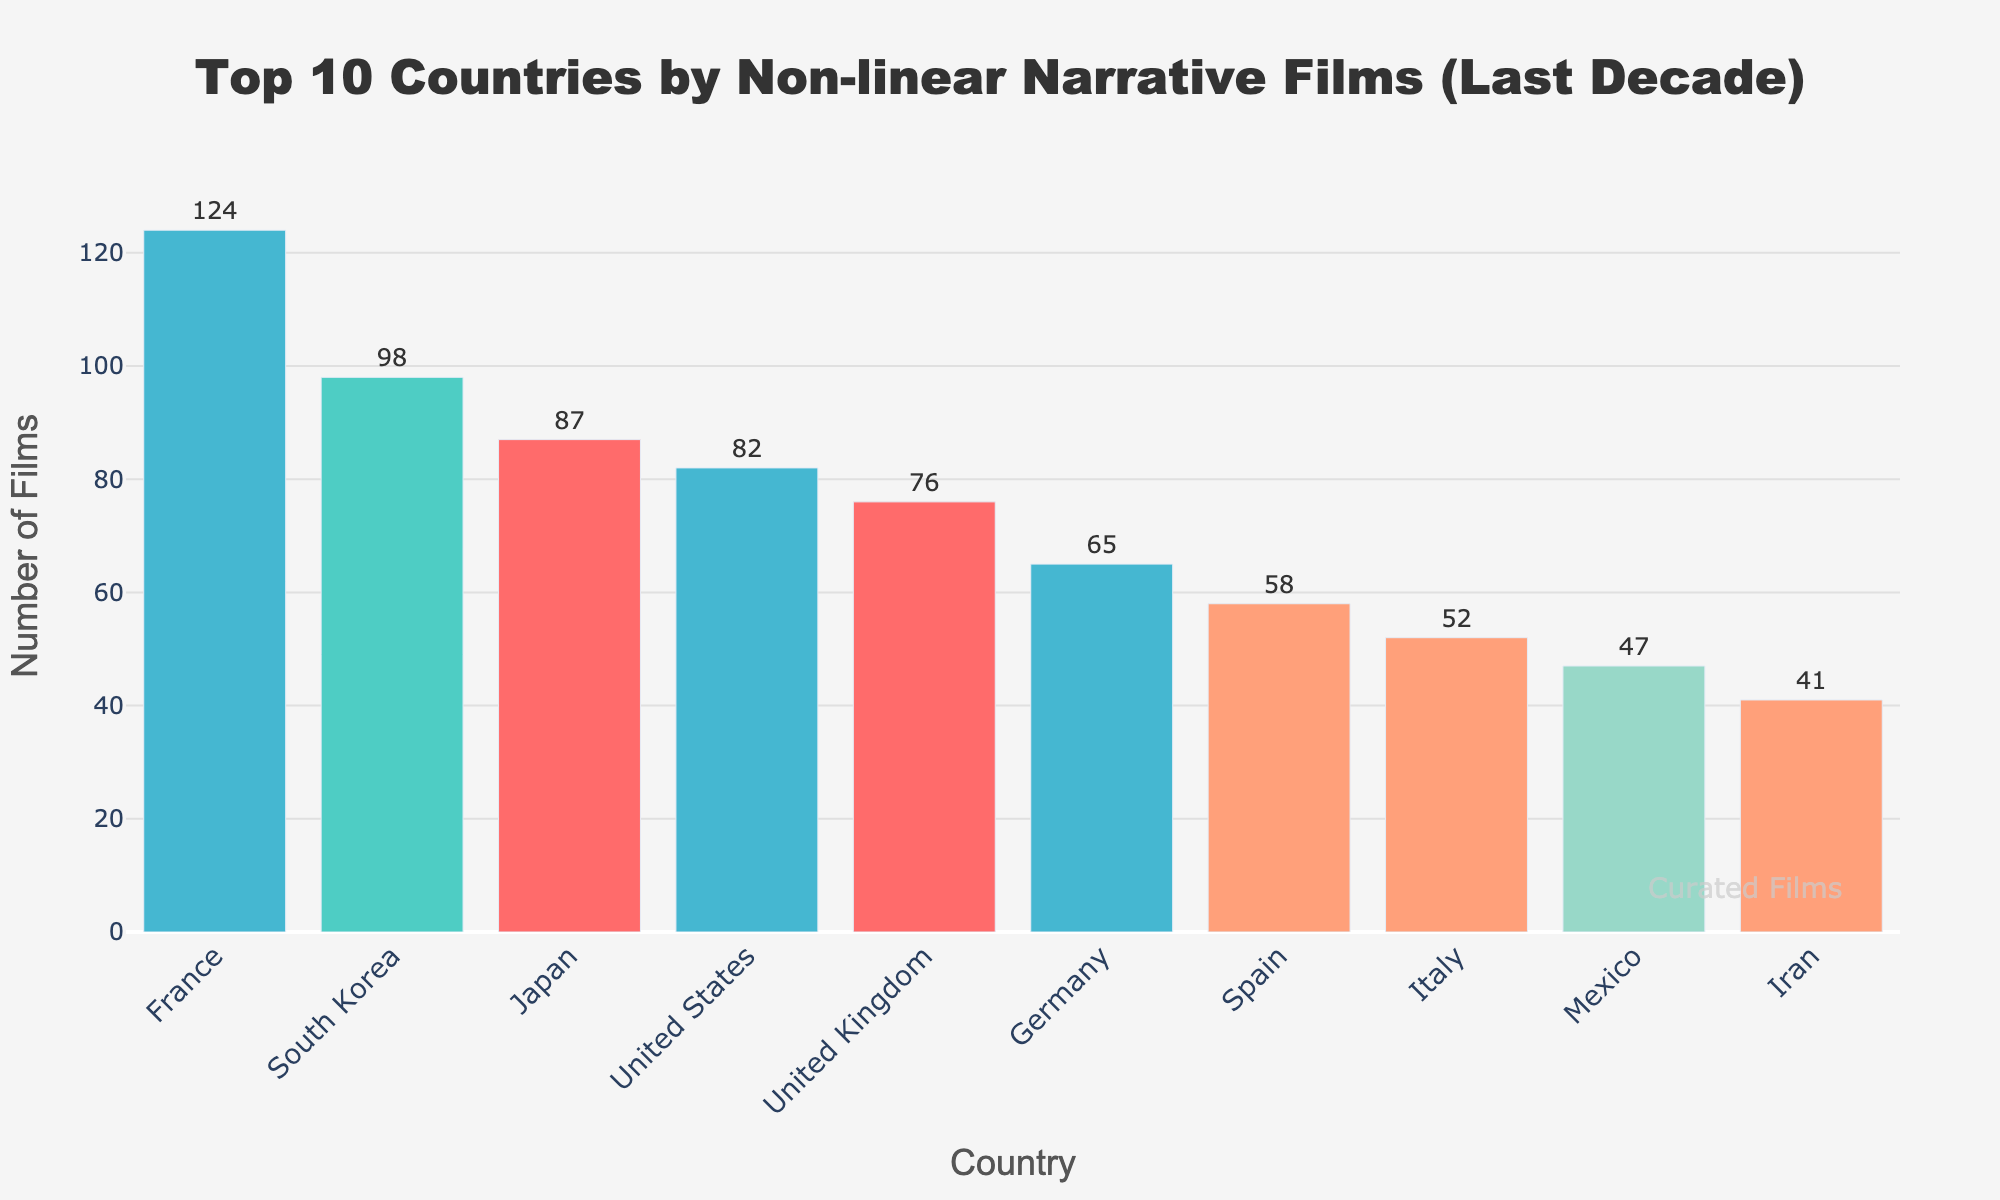what country produced the most non-linear narrative films? France produced the most non-linear narrative films with 124 films. This is observed by looking at the height of the bars where France's bar is the tallest.
Answer: France which country produced fewer non-linear narrative films, Spain or Germany? Germany produced more non-linear narrative films than Spain. Observing the bars, Germany's bar is taller with 65 films, while Spain's bar has 58 films.
Answer: Spain what is the combined total of non-linear narrative films produced by Japan and Mexico? Japan produced 87 films and Mexico produced 47 films. Adding these two numbers gives the combined total: 87 + 47 = 134.
Answer: 134 how many more non-linear narrative films did France produce compared to Italy? France produced 124 films and Italy produced 52 films. The difference is 124 - 52 = 72 films.
Answer: 72 which countries produced more than 80 non-linear narrative films? The countries that produced more than 80 films are France, South Korea, Japan, and the United States. This is determined by observing the bars that reach above the 80-mark on the y-axis.
Answer: France, South Korea, Japan, United States what is the average number of non-linear narrative films produced by the top three countries? The top three countries are France, South Korea, and Japan, producing 124, 98, and 87 films respectively. The average is calculated by summing these numbers: 124 + 98 + 87 = 309, then dividing by 3. 309 / 3 = 103.
Answer: 103 what is the difference in non-linear narrative films produced between the country with the maximum and minimum films? France produced the maximum with 124 films and Iran produced the minimum with 41 films. The difference is 124 - 41 = 83 films.
Answer: 83 what is the median number of non-linear narrative films produced by the listed countries? To find the median, first, list the number of films in ascending order: 41, 47, 52, 58, 65, 76, 82, 87, 98, 124. The median is the average of the 5th and 6th values (65 and 76). Therefore, (65 + 76) / 2 = 70.5.
Answer: 70.5 how many countries produced between 50 and 100 non-linear narrative films? The countries falling within this range are Japan (87), United States (82), United Kingdom (76), Germany (65), Spain (58), and Italy (52). Counting these gives a total of 6 countries.
Answer: 6 